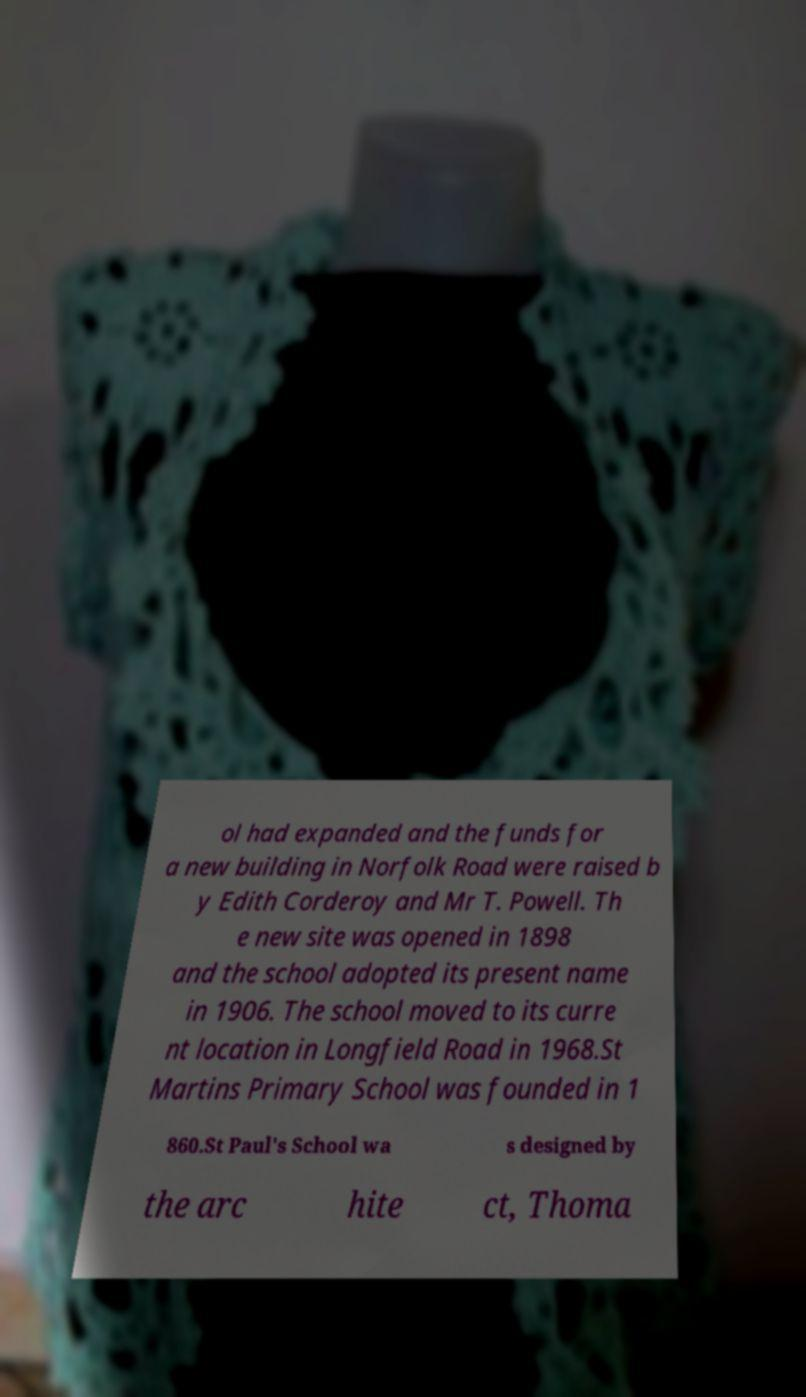Can you accurately transcribe the text from the provided image for me? ol had expanded and the funds for a new building in Norfolk Road were raised b y Edith Corderoy and Mr T. Powell. Th e new site was opened in 1898 and the school adopted its present name in 1906. The school moved to its curre nt location in Longfield Road in 1968.St Martins Primary School was founded in 1 860.St Paul's School wa s designed by the arc hite ct, Thoma 